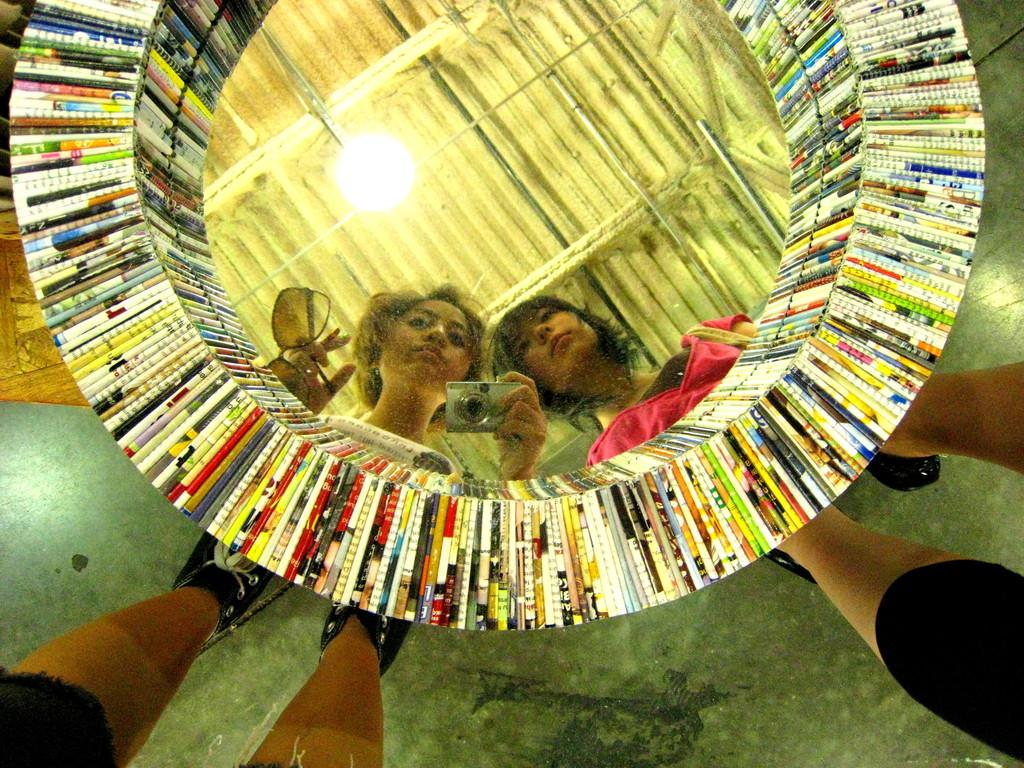How many people are in the image? There are two people in the image. What can be seen in the image besides the people? The people are reflected in a mirror, and they are holding a camera and glasses. There is also a light and colorful books in the image. What part of the people's bodies can be seen in the image? The people's legs are visible in the image. What type of juice is being served in the image? There is no juice present in the image. How many houses can be seen in the image? There are no houses visible in the image. 